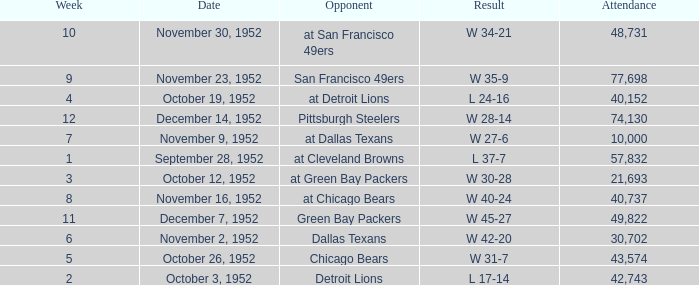When is the last week that has a result of a w 34-21? 10.0. 